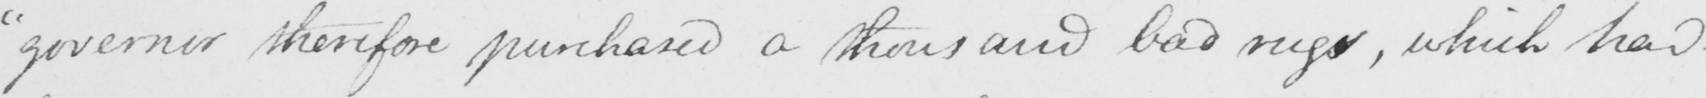Can you tell me what this handwritten text says? " governor therefore purchased a thousand bad rugs , which had 